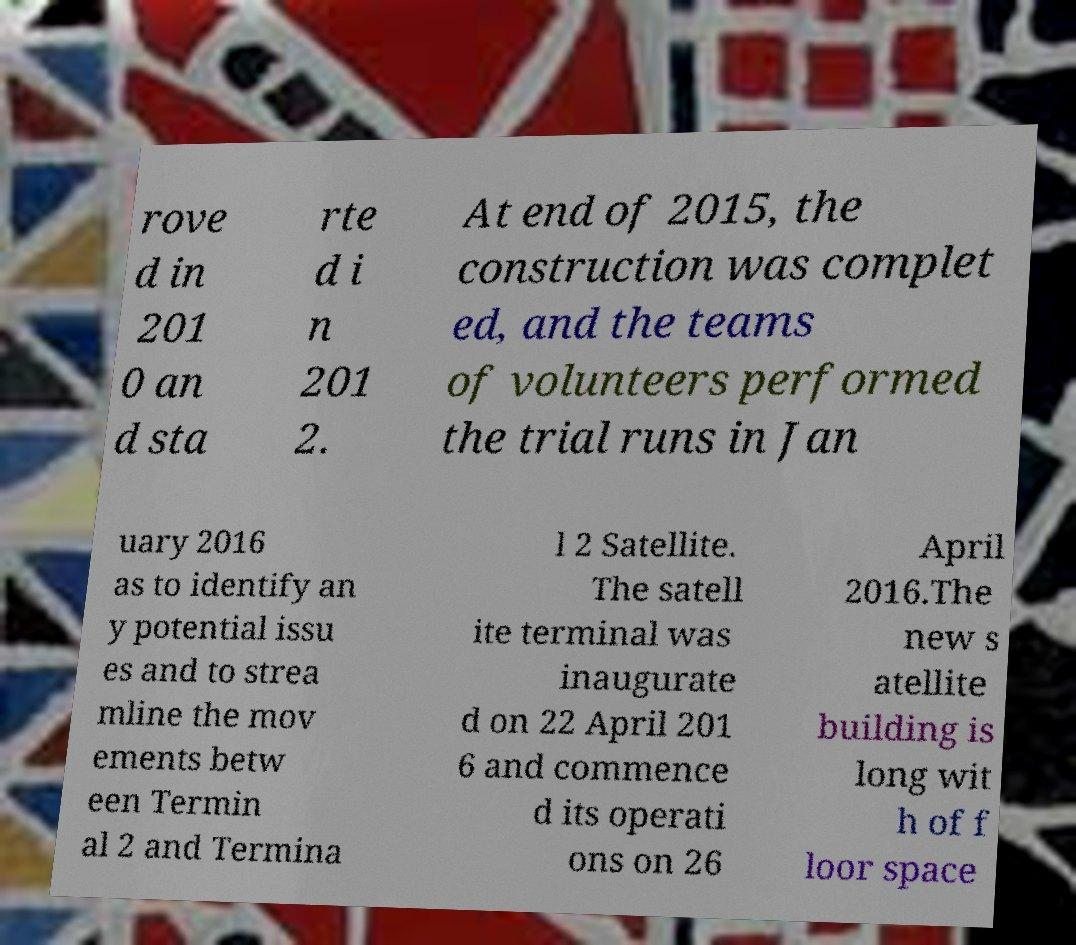Could you assist in decoding the text presented in this image and type it out clearly? rove d in 201 0 an d sta rte d i n 201 2. At end of 2015, the construction was complet ed, and the teams of volunteers performed the trial runs in Jan uary 2016 as to identify an y potential issu es and to strea mline the mov ements betw een Termin al 2 and Termina l 2 Satellite. The satell ite terminal was inaugurate d on 22 April 201 6 and commence d its operati ons on 26 April 2016.The new s atellite building is long wit h of f loor space 